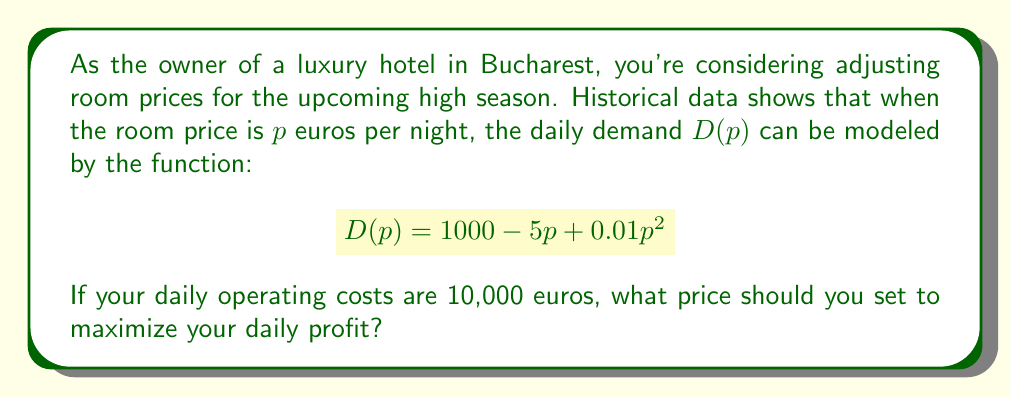Give your solution to this math problem. Let's approach this step-by-step:

1) First, we need to define the profit function. Profit is revenue minus costs:
   $$\text{Profit} = \text{Revenue} - \text{Costs}$$

2) Revenue is price times quantity demanded:
   $$\text{Revenue} = p \cdot D(p) = p(1000 - 5p + 0.01p^2)$$

3) Daily costs are given as 10,000 euros. So our profit function is:
   $$\text{Profit} = p(1000 - 5p + 0.01p^2) - 10000$$

4) To maximize profit, we need to find where the derivative of the profit function equals zero:
   $$\frac{d}{dp}(\text{Profit}) = 1000 - 10p + 0.03p^2 + p(-5 + 0.02p) = 0$$

5) Simplifying:
   $$1000 - 15p + 0.05p^2 = 0$$

6) This is a quadratic equation. We can solve it using the quadratic formula:
   $$p = \frac{15 \pm \sqrt{15^2 - 4(0.05)(1000)}}{2(0.05)}$$

7) Solving this:
   $$p \approx 153.83 \text{ or } 146.17$$

8) To determine which of these gives the maximum profit (rather than minimum), we can check the second derivative:
   $$\frac{d^2}{dp^2}(\text{Profit}) = -15 + 0.1p$$

9) At $p = 153.83$, this is positive, indicating a minimum. At $p = 146.17$, it's negative, indicating a maximum.

Therefore, to maximize profit, the optimal price is approximately 146.17 euros per night.
Answer: 146.17 euros 